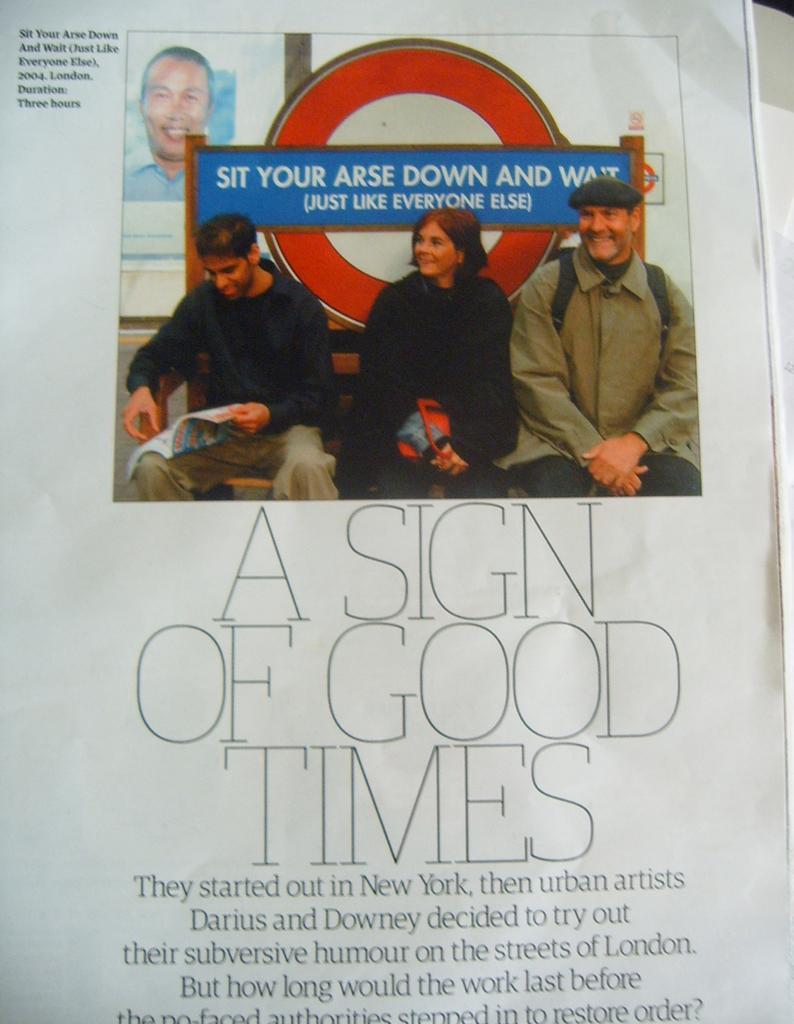Please provide a concise description of this image. This image consists of a poster with a few images of two men, a woman and there is a text on it. 